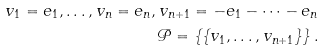<formula> <loc_0><loc_0><loc_500><loc_500>v _ { 1 } = e _ { 1 } , \dots , v _ { n } = e _ { n } , v _ { n + 1 } = - e _ { 1 } - \dots - e _ { n } \\ { \mathcal { P } } = \left \{ \{ v _ { 1 } , \dots , v _ { n + 1 } \} \right \} .</formula> 